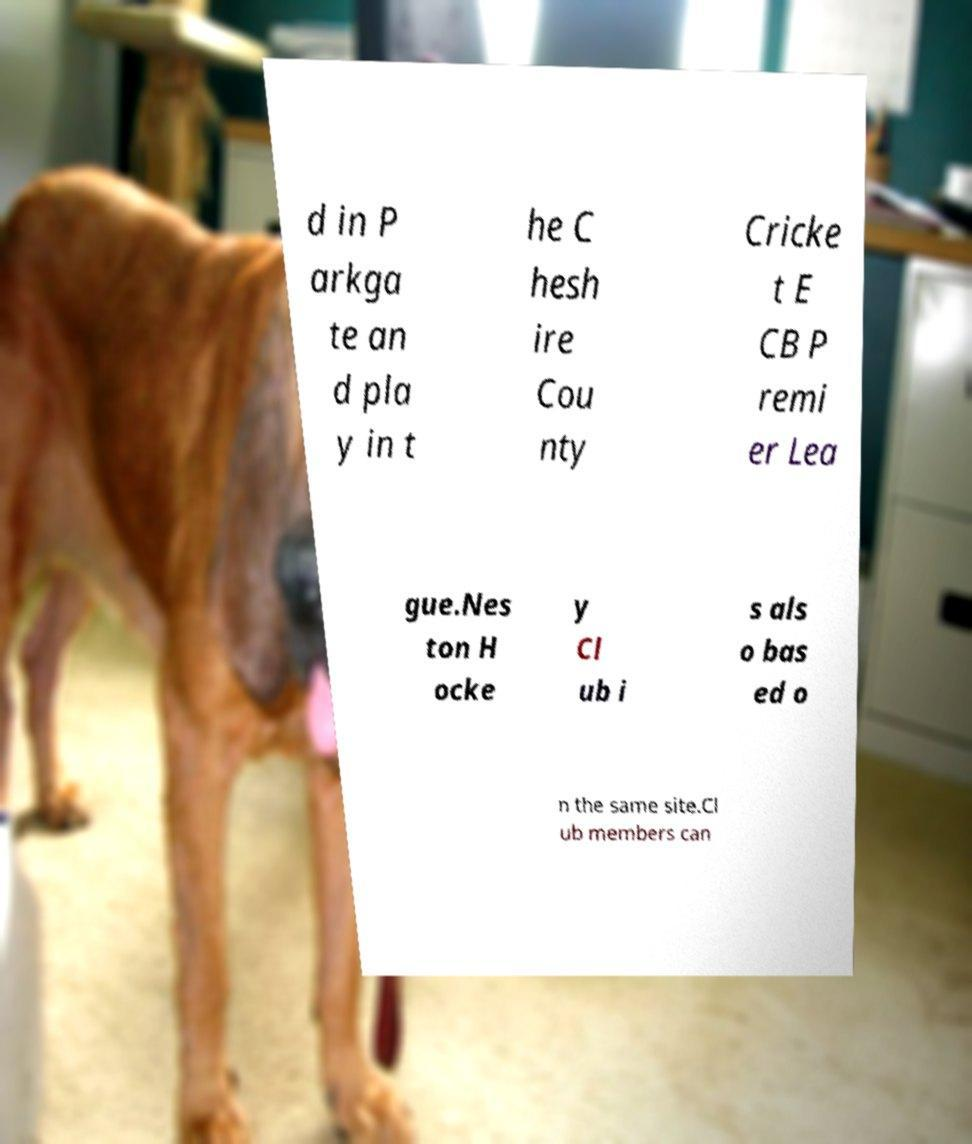Please read and relay the text visible in this image. What does it say? d in P arkga te an d pla y in t he C hesh ire Cou nty Cricke t E CB P remi er Lea gue.Nes ton H ocke y Cl ub i s als o bas ed o n the same site.Cl ub members can 